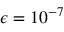<formula> <loc_0><loc_0><loc_500><loc_500>\epsilon = 1 0 ^ { - 7 }</formula> 